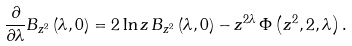<formula> <loc_0><loc_0><loc_500><loc_500>\frac { \partial } { \partial \lambda } B _ { z ^ { 2 } } \left ( \lambda , 0 \right ) = 2 \ln z \, B _ { z ^ { 2 } } \left ( \lambda , 0 \right ) - z ^ { 2 \lambda } \, \Phi \left ( z ^ { 2 } , 2 , \lambda \right ) .</formula> 